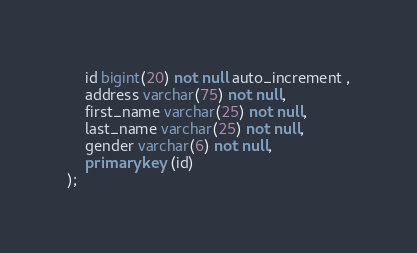<code> <loc_0><loc_0><loc_500><loc_500><_SQL_>	id bigint(20) not null auto_increment ,
	address varchar(75) not null,
	first_name varchar(25) not null,
	last_name varchar(25) not null,
	gender varchar(6) not null,
	primary key (id)
);</code> 